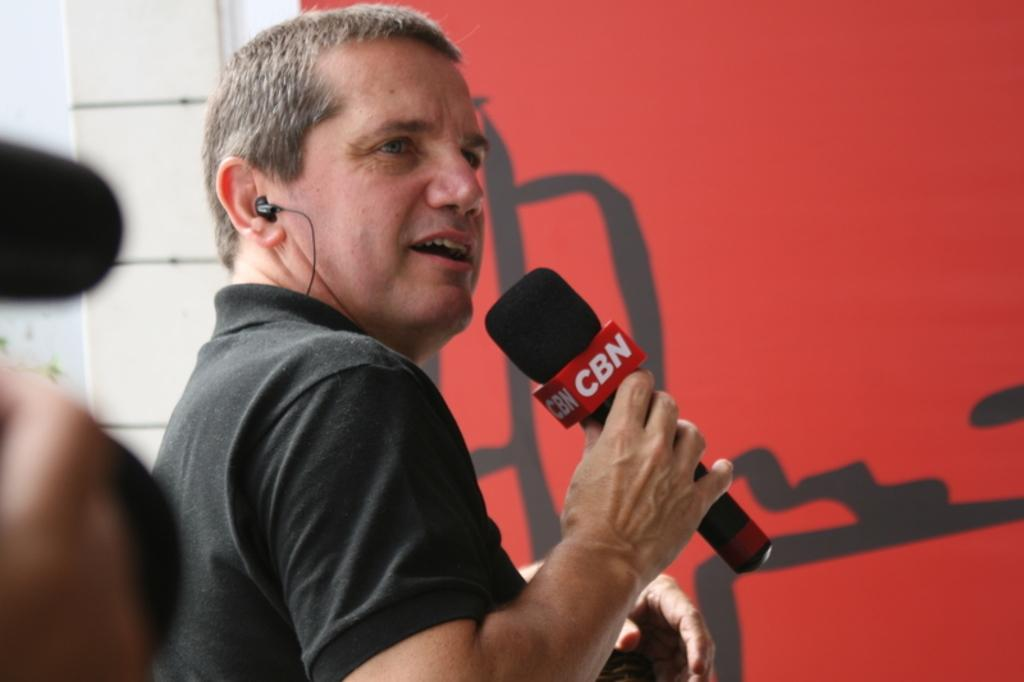What is the man in the image doing? The man is standing in the image and holding a microphone in his hand. What else can be seen in the image related to the man's activity? The man has headphones in his ears. What can be seen in the background of the image? There is a red-colored poster in the background of the image. What is the queen's opinion on the railway system in the image? There is no queen or railway system present in the image, so it is not possible to determine her opinion. 